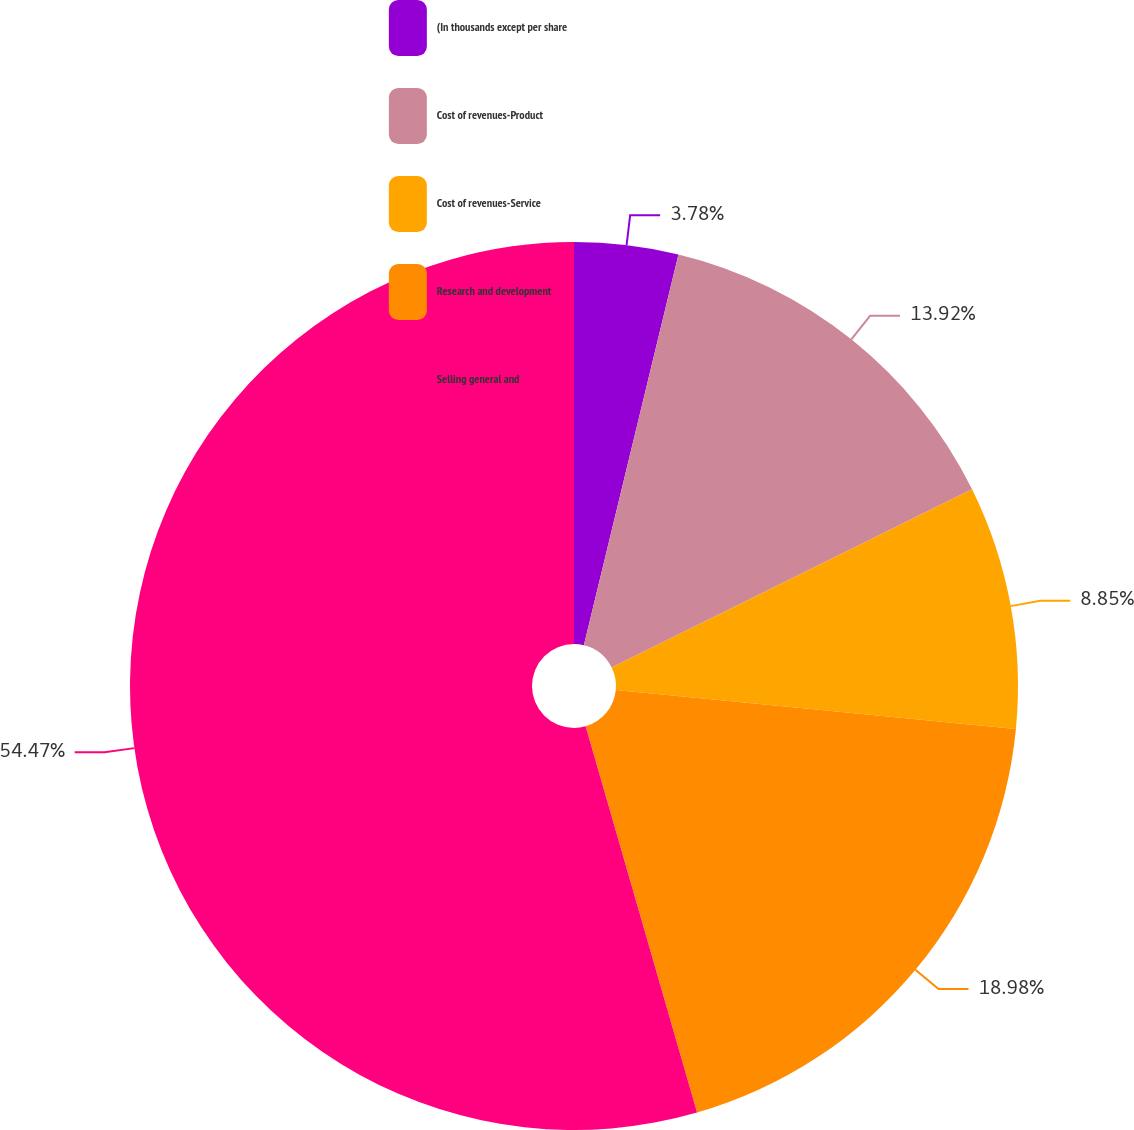Convert chart. <chart><loc_0><loc_0><loc_500><loc_500><pie_chart><fcel>(In thousands except per share<fcel>Cost of revenues-Product<fcel>Cost of revenues-Service<fcel>Research and development<fcel>Selling general and<nl><fcel>3.78%<fcel>13.92%<fcel>8.85%<fcel>18.99%<fcel>54.48%<nl></chart> 